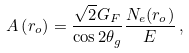Convert formula to latex. <formula><loc_0><loc_0><loc_500><loc_500>A \left ( r _ { o } \right ) = \frac { \sqrt { 2 } G _ { F } } { \cos 2 \theta _ { g } } \frac { N _ { e } ( r _ { o } ) } { E } \, ,</formula> 